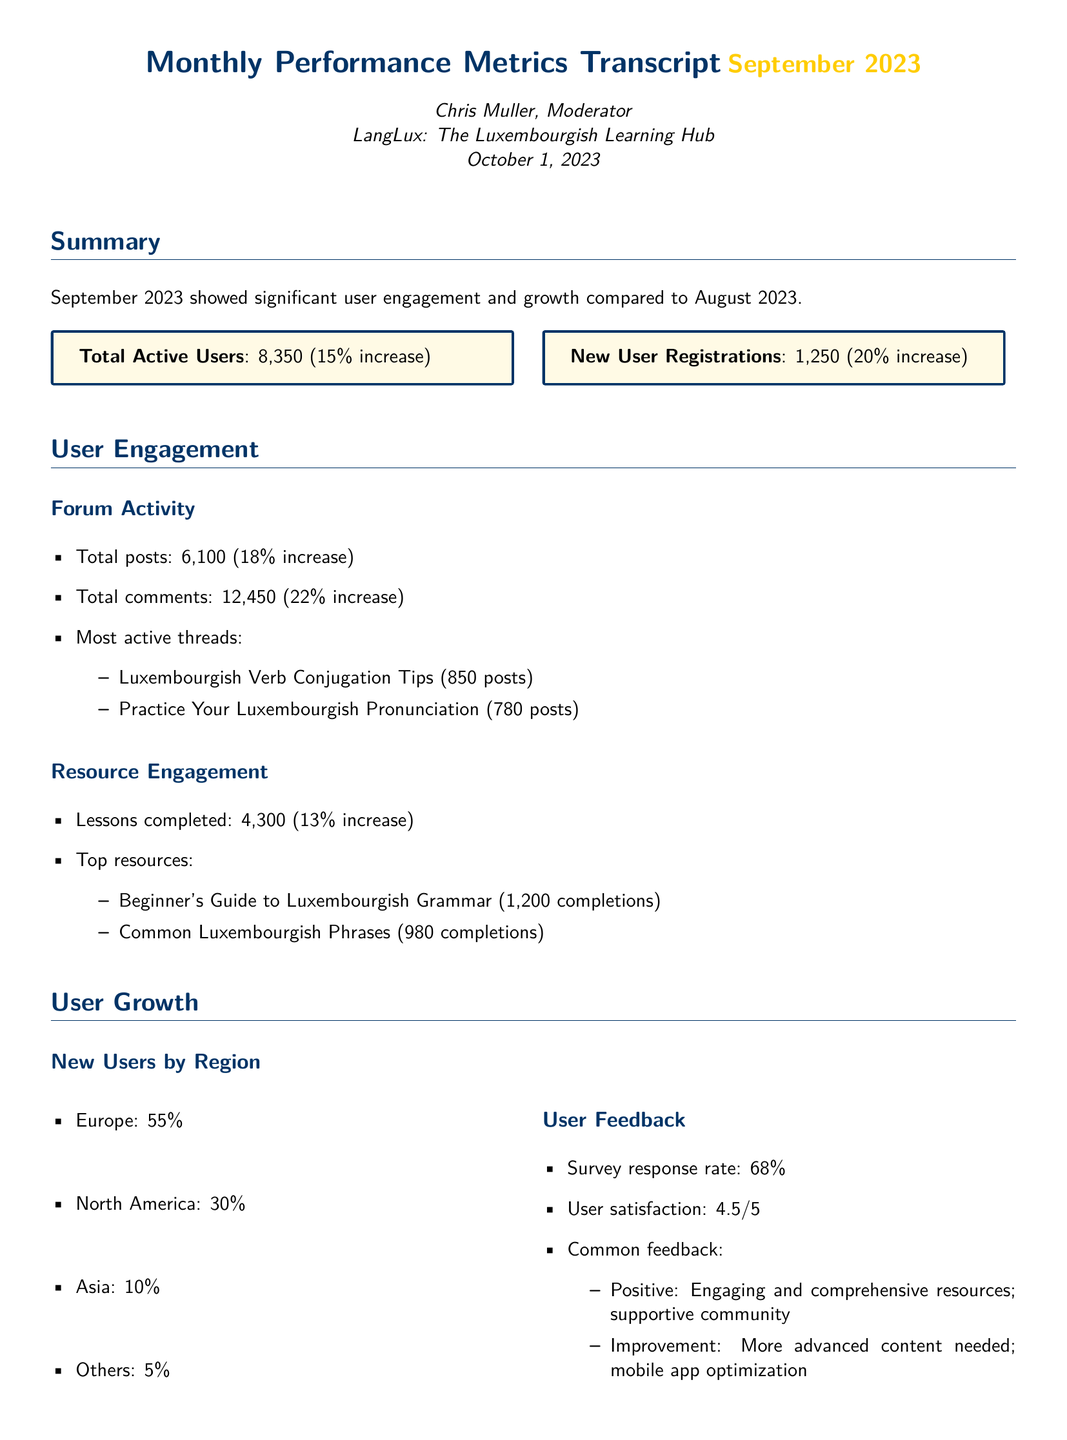What is the total number of active users? The total active users increased from August to September 2023, which is reported as 8,350.
Answer: 8,350 How many new user registrations were there in September 2023? The document states that new user registrations increased by 20%, totaling 1,250 in September 2023.
Answer: 1,250 What was the increase percentage in total posts? The increase in total posts is mentioned as 18% compared to the previous month.
Answer: 18% Which resource had the most completions? The document specifies that the Beginner's Guide to Luxembourgish Grammar had the highest completions at 1,200.
Answer: Beginner's Guide to Luxembourgish Grammar What is the user satisfaction rating? The survey indicated that user satisfaction is rated at 4.5 out of 5.
Answer: 4.5/5 Which region contributed the most new users? The document states that Europe contributed the highest percentage of new users at 55%.
Answer: Europe What is the common feedback for improvement? The document lists that users mentioned needing more advanced content as an area for improvement.
Answer: More advanced content needed Who authored the transcript? The transcript is authored by Chris Muller, who is identified as the Moderator.
Answer: Chris Muller What are the next steps indicated in the conclusion? The next steps highlighted involve developing advanced Luxembourgish content and optimizing the mobile app.
Answer: Developing advanced Luxembourgish content and addressing technical optimizations for mobile users 